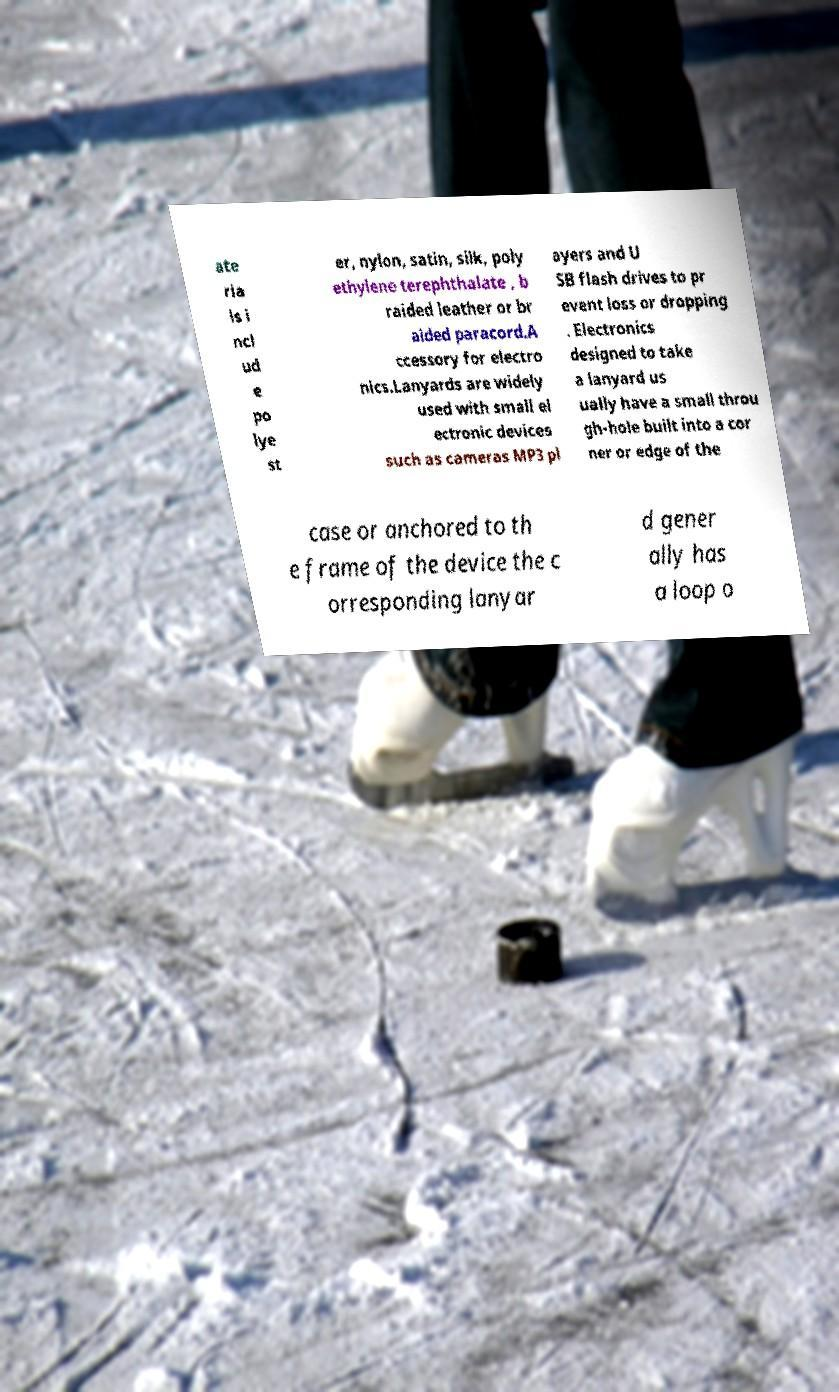Please identify and transcribe the text found in this image. ate ria ls i ncl ud e po lye st er, nylon, satin, silk, poly ethylene terephthalate , b raided leather or br aided paracord.A ccessory for electro nics.Lanyards are widely used with small el ectronic devices such as cameras MP3 pl ayers and U SB flash drives to pr event loss or dropping . Electronics designed to take a lanyard us ually have a small throu gh-hole built into a cor ner or edge of the case or anchored to th e frame of the device the c orresponding lanyar d gener ally has a loop o 